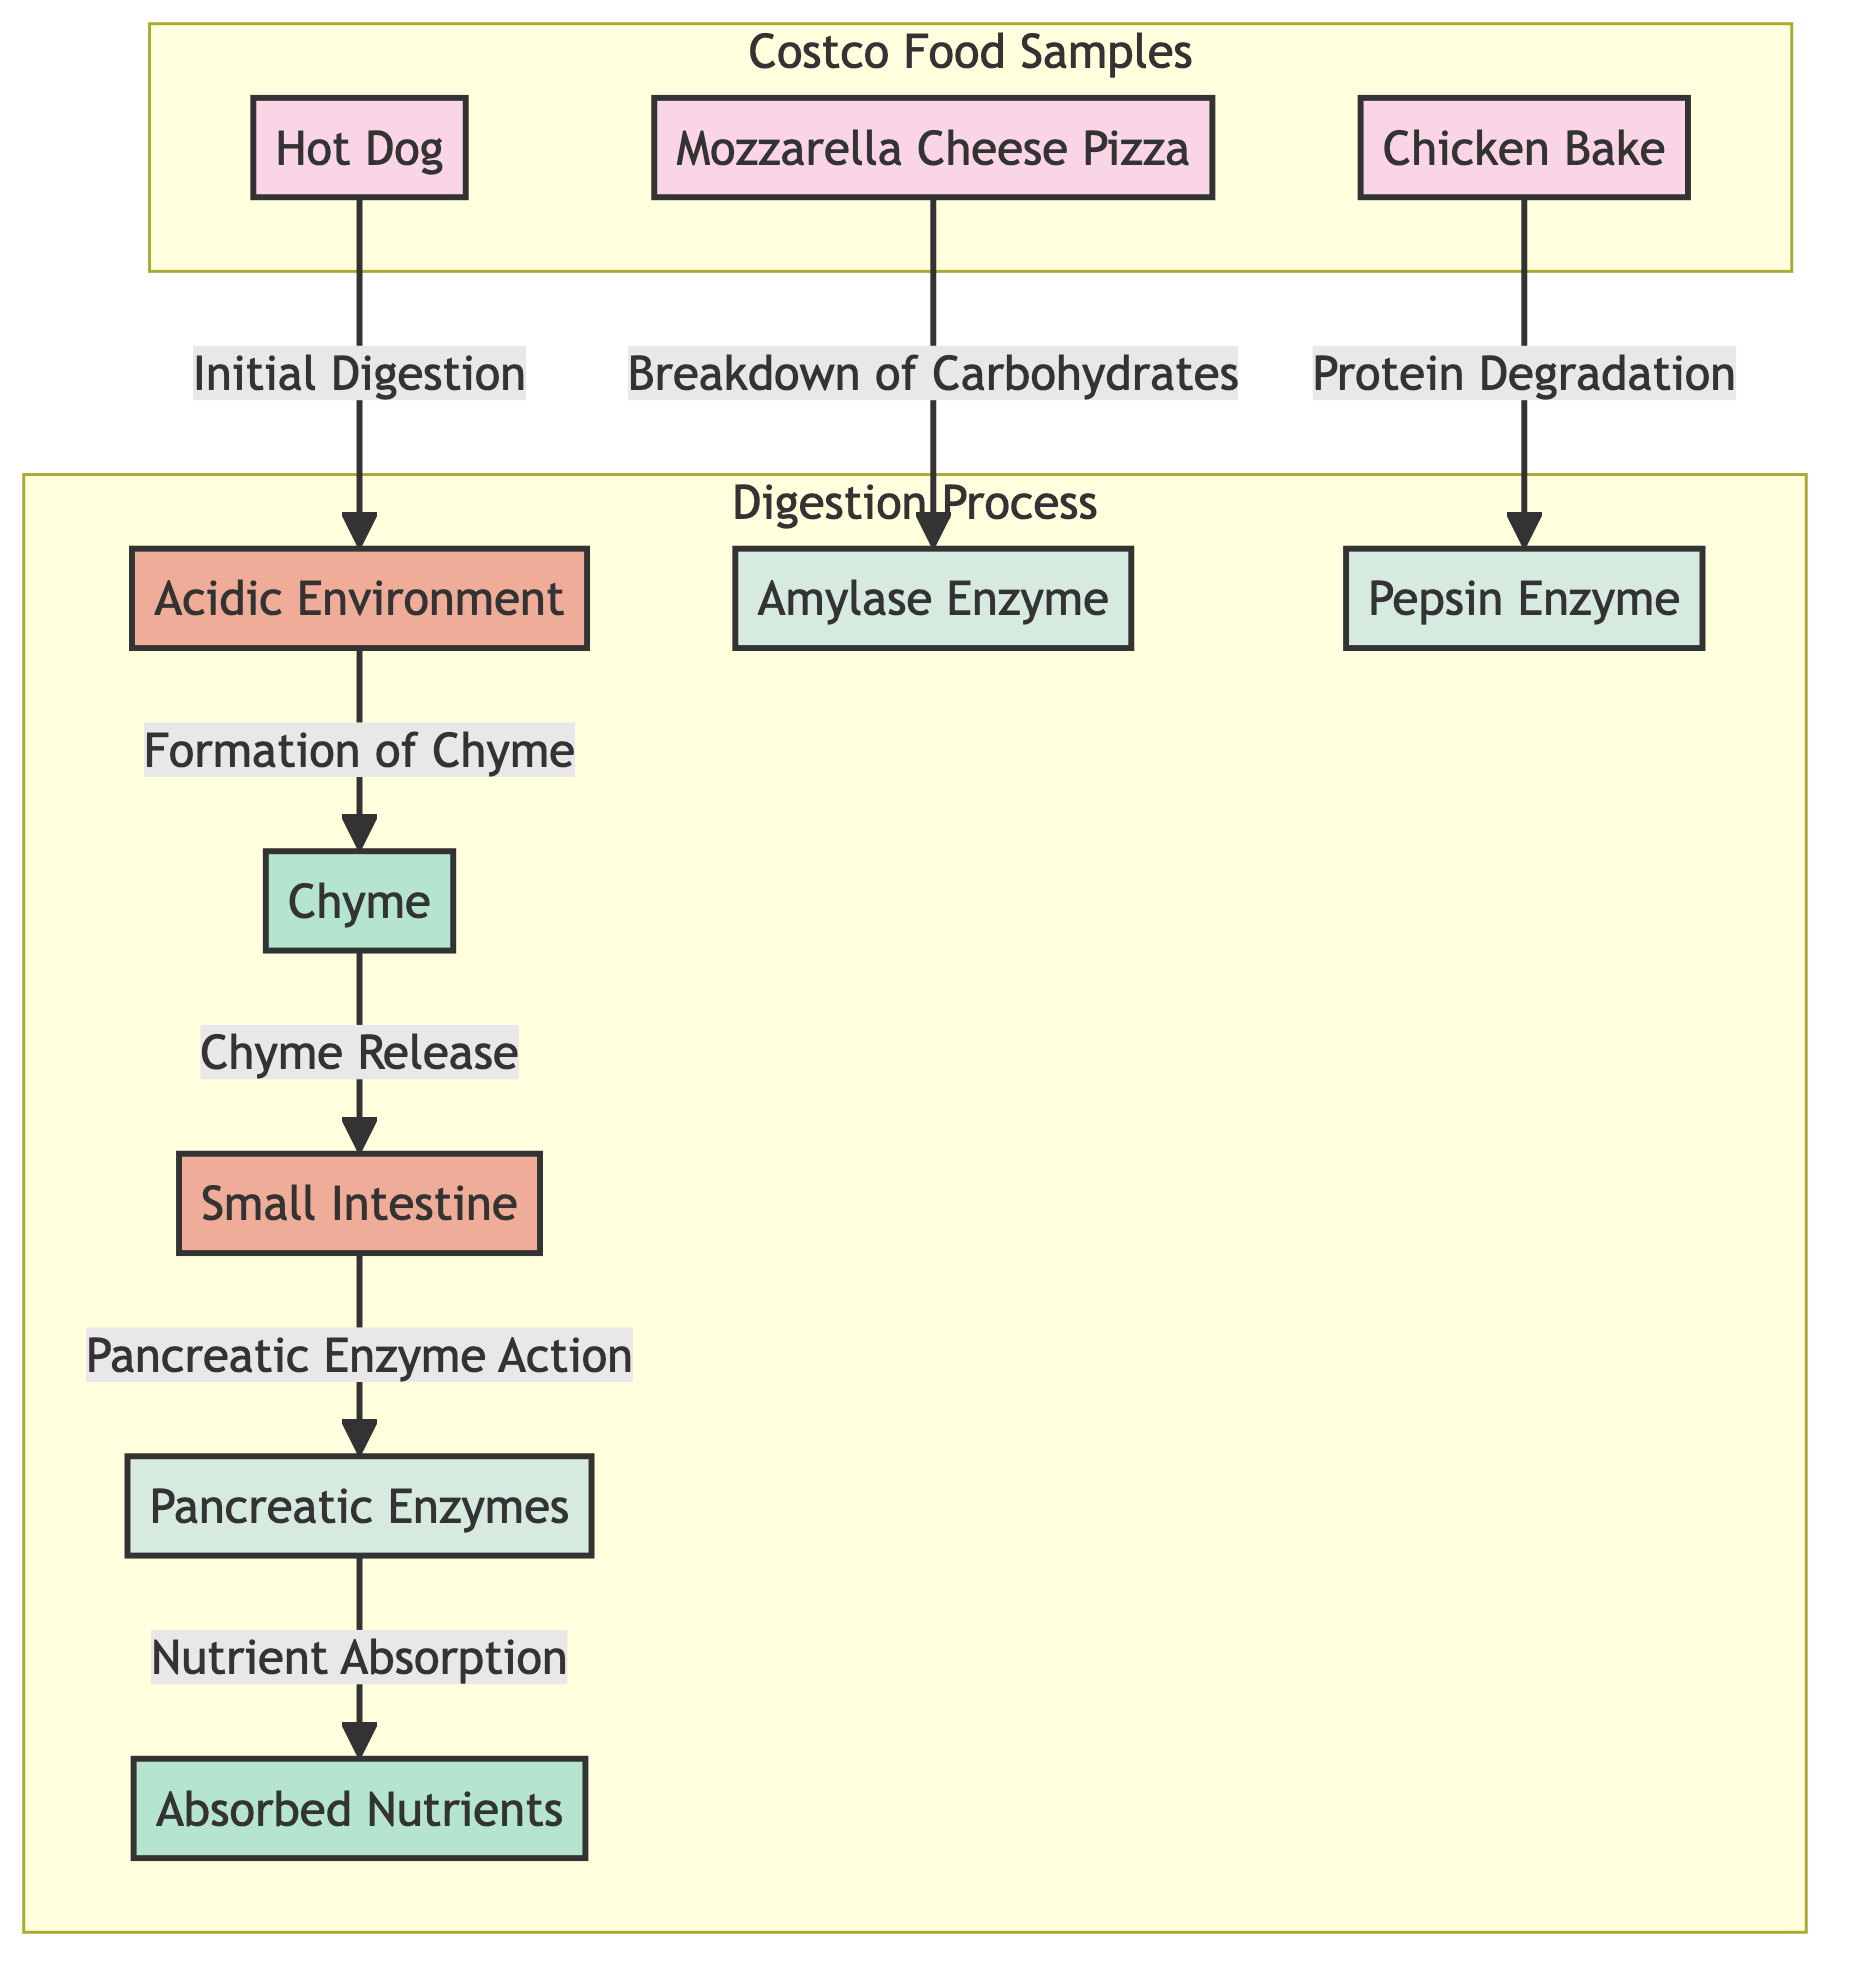What are the three food samples represented in the diagram? The diagram shows three food samples labeled: Mozzarella Cheese Pizza, Chicken Bake, and Hot Dog. Each food sample is presented in a distinct node under the "Costco Food Samples" subgraph.
Answer: Mozzarella Cheese Pizza, Chicken Bake, Hot Dog Which enzyme is associated with protein degradation? In the diagram, the enzyme labeled "Pepsin Enzyme" is specifically linked to the process of protein degradation, indicated by an arrow flowing from Chicken Bake to Pepsin Enzyme.
Answer: Pepsin Enzyme How many processes are involved in the digestion pathway? The digestion pathway in the diagram includes three distinct processes: Formation of Chyme, Chyme Release, and Nutrient Absorption. This can be determined by counting the process nodes in the "Digestion Process" subgraph.
Answer: 3 What is the function of Amylase Enzyme in the diagram? The function of Amylase Enzyme is indicated by the arrow showing the "Breakdown of Carbohydrates" associated with the Mozzarella Cheese Pizza. This relationship represents that Amylase Enzyme functions specifically for carbohydrate breakdown in this context.
Answer: Breakdown of Carbohydrates After the formation of Chyme, what organ is involved next in the digestion process? Following the Formation of Chyme indicated in the diagram, the next organ involved in the digestion process is the Small Intestine. This is shown by the flow from Chyme to Small Intestine with the label "Chyme Release."
Answer: Small Intestine What is the final product of the digestion pathway as shown in the diagram? The final product of the digestion pathway is labeled as "Absorbed Nutrients." This is indicated by the last node in the flow where nutrient absorption occurs after the action of Pancreatic Enzymes.
Answer: Absorbed Nutrients How many enzymes are shown in the digestion process? There are three enzymes depicted in the digestion process within the diagram: Amylase Enzyme, Pepsin Enzyme, and Pancreatic Enzymes. This can be observed by counting the enzyme nodes in the sequence of digestion processes.
Answer: 3 Which food sample is linked to the initial digestion in an acidic environment? The Hot Dog, represented in the diagram, is the food sample linked to the "Initial Digestion" process in the "Acidic Environment." This relationship is indicated with the flow pointing from Hot Dog to Acidic Environment.
Answer: Hot Dog 